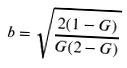<formula> <loc_0><loc_0><loc_500><loc_500>b = \sqrt { \frac { 2 ( 1 - G ) } { G ( 2 - G ) } }</formula> 